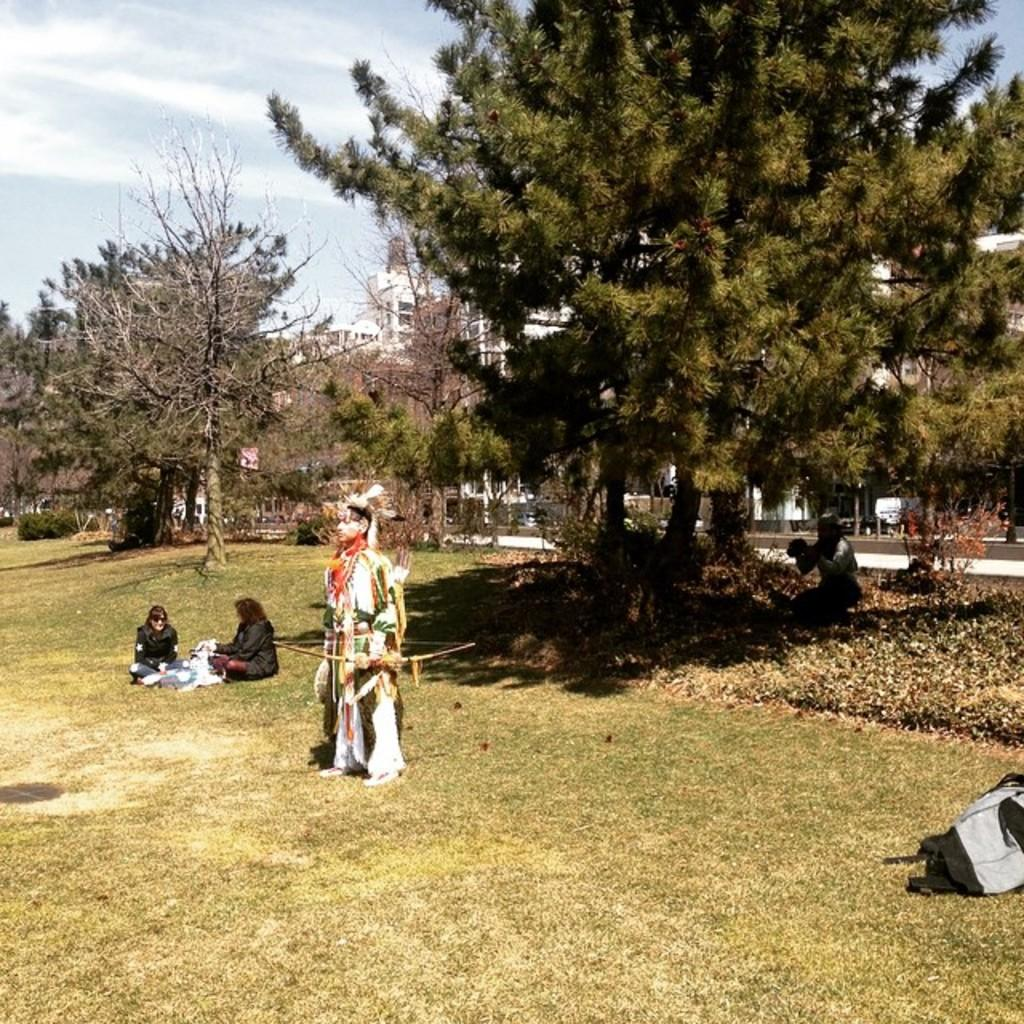What is the primary setting of the image? The primary setting of the image is on the grass. What type of vegetation can be seen in the image? There are plants and trees in the image. What object is present that might be used for carrying items? There is a bag in the image. How many people are visible in the image? There is at least one person in the image. What can be seen in the background of the image? There are buildings, a walkway, and the sky visible in the background of the image. What type of button is being discussed in the meeting in the image? There is no meeting or button present in the image. What is the distance between the trees and the buildings in the image? The image does not provide a scale or reference point to determine the distance between the trees and the buildings. 